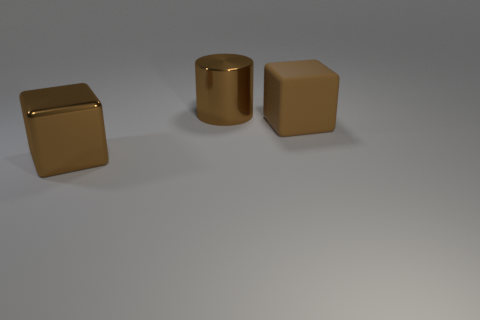Add 3 matte balls. How many objects exist? 6 Subtract all cylinders. How many objects are left? 2 Subtract all large brown cylinders. Subtract all small yellow matte cubes. How many objects are left? 2 Add 3 big cylinders. How many big cylinders are left? 4 Add 1 brown metallic blocks. How many brown metallic blocks exist? 2 Subtract 0 blue spheres. How many objects are left? 3 